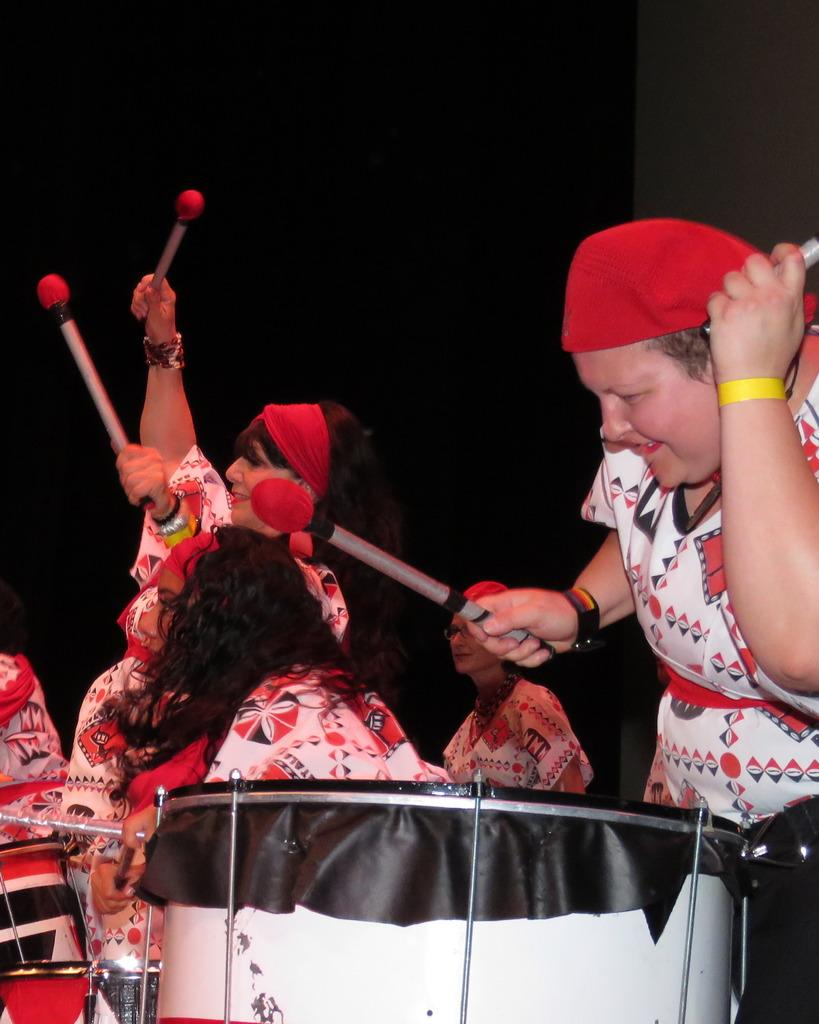How many people are in the image? There are persons in the image. What are the persons in the image doing? The persons are playing drums. Can you see any quivers in the image? There is no mention of quivers in the provided facts, and therefore, we cannot determine if any are present in the image. How loud is the quiet in the image? The provided facts do not mention any specific sound levels or the presence of quietness in the image. 